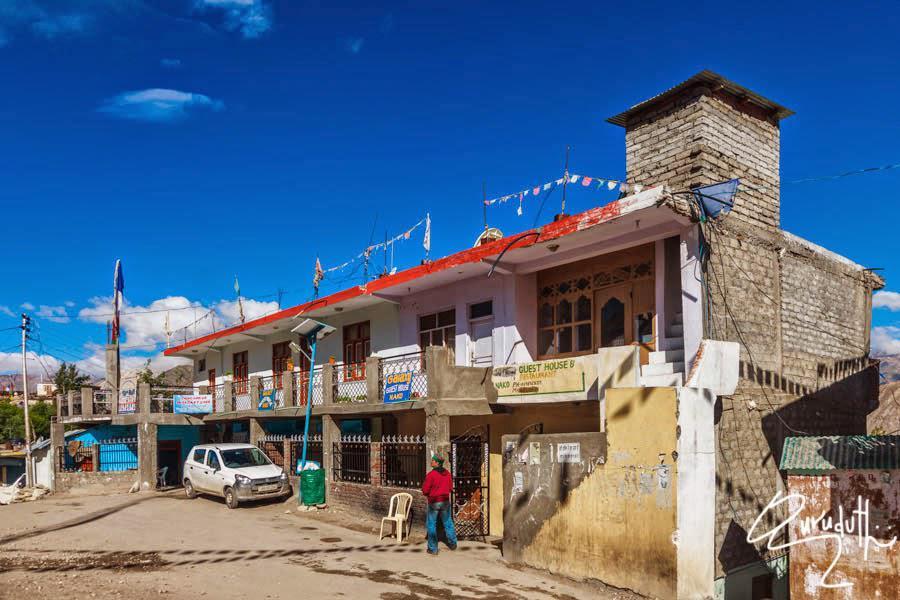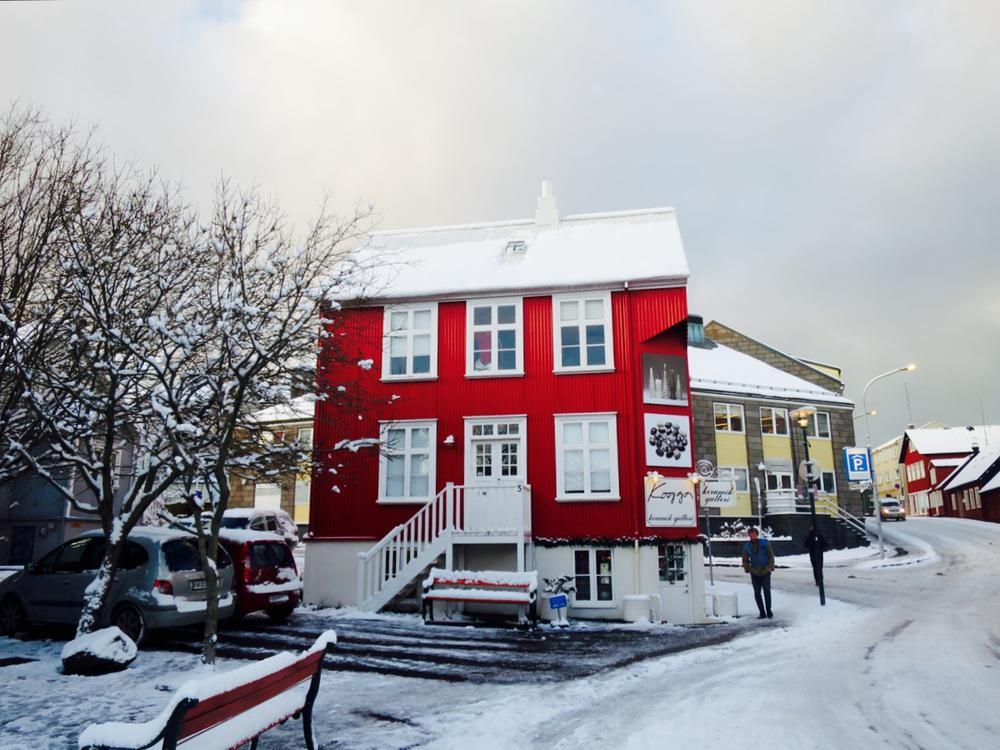The first image is the image on the left, the second image is the image on the right. Considering the images on both sides, is "At least one image shows a harbor and an expanse of water leading into a narrower canal lined with houses and other buildings." valid? Answer yes or no. No. The first image is the image on the left, the second image is the image on the right. Assess this claim about the two images: "Boats float in the water on a sunny day in the image on the right.". Correct or not? Answer yes or no. No. 